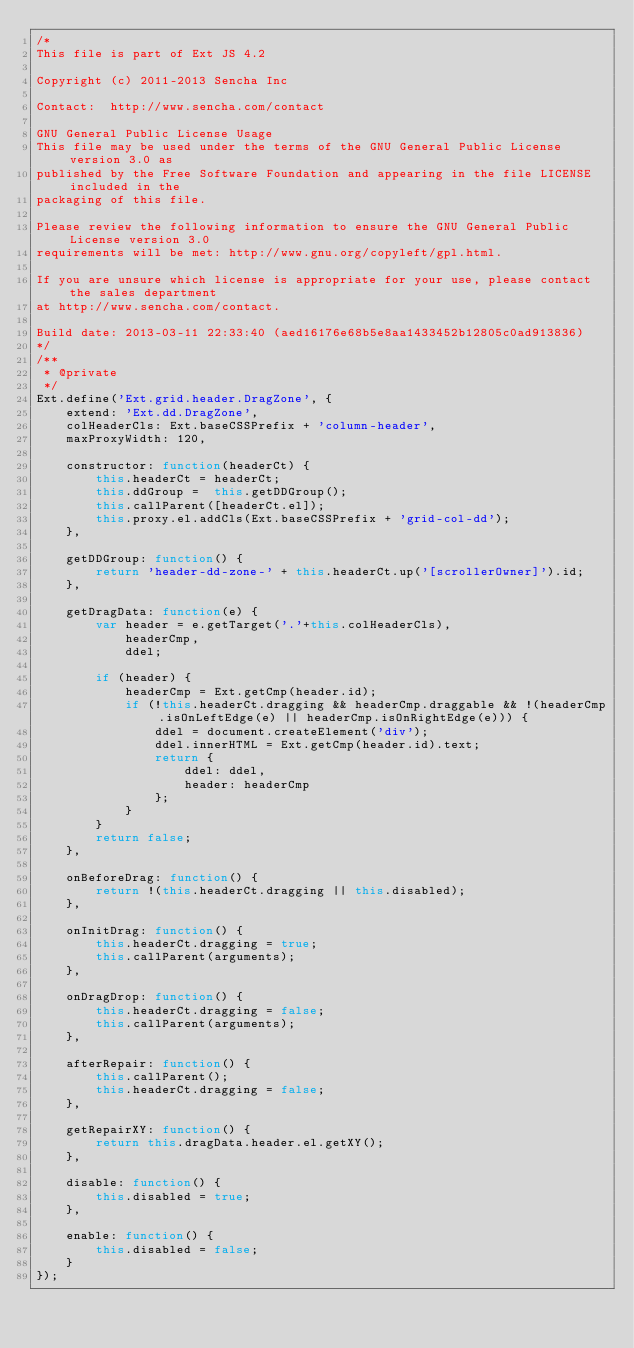Convert code to text. <code><loc_0><loc_0><loc_500><loc_500><_JavaScript_>/*
This file is part of Ext JS 4.2

Copyright (c) 2011-2013 Sencha Inc

Contact:  http://www.sencha.com/contact

GNU General Public License Usage
This file may be used under the terms of the GNU General Public License version 3.0 as
published by the Free Software Foundation and appearing in the file LICENSE included in the
packaging of this file.

Please review the following information to ensure the GNU General Public License version 3.0
requirements will be met: http://www.gnu.org/copyleft/gpl.html.

If you are unsure which license is appropriate for your use, please contact the sales department
at http://www.sencha.com/contact.

Build date: 2013-03-11 22:33:40 (aed16176e68b5e8aa1433452b12805c0ad913836)
*/
/**
 * @private
 */
Ext.define('Ext.grid.header.DragZone', {
    extend: 'Ext.dd.DragZone',
    colHeaderCls: Ext.baseCSSPrefix + 'column-header',
    maxProxyWidth: 120,

    constructor: function(headerCt) {
        this.headerCt = headerCt;
        this.ddGroup =  this.getDDGroup();
        this.callParent([headerCt.el]);
        this.proxy.el.addCls(Ext.baseCSSPrefix + 'grid-col-dd');
    },

    getDDGroup: function() {
        return 'header-dd-zone-' + this.headerCt.up('[scrollerOwner]').id;
    },

    getDragData: function(e) {
        var header = e.getTarget('.'+this.colHeaderCls),
            headerCmp,
            ddel;

        if (header) {
            headerCmp = Ext.getCmp(header.id);
            if (!this.headerCt.dragging && headerCmp.draggable && !(headerCmp.isOnLeftEdge(e) || headerCmp.isOnRightEdge(e))) {
                ddel = document.createElement('div');
                ddel.innerHTML = Ext.getCmp(header.id).text;
                return {
                    ddel: ddel,
                    header: headerCmp
                };
            }
        }
        return false;
    },

    onBeforeDrag: function() {
        return !(this.headerCt.dragging || this.disabled);
    },

    onInitDrag: function() {
        this.headerCt.dragging = true;
        this.callParent(arguments);
    },

    onDragDrop: function() {
        this.headerCt.dragging = false;
        this.callParent(arguments);
    },

    afterRepair: function() {
        this.callParent();
        this.headerCt.dragging = false;
    },

    getRepairXY: function() {
        return this.dragData.header.el.getXY();
    },
    
    disable: function() {
        this.disabled = true;
    },
    
    enable: function() {
        this.disabled = false;
    }
});
</code> 